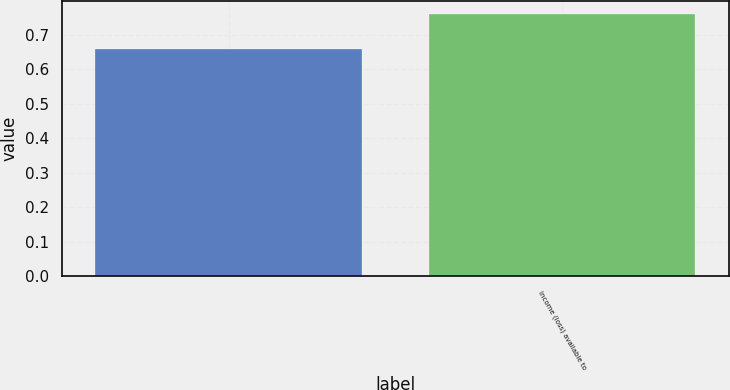Convert chart to OTSL. <chart><loc_0><loc_0><loc_500><loc_500><bar_chart><ecel><fcel>Income (loss) available to<nl><fcel>0.66<fcel>0.76<nl></chart> 